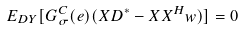<formula> <loc_0><loc_0><loc_500><loc_500>E _ { D Y } [ G ^ { C } _ { \sigma } ( e ) ( X D ^ { * } - X X ^ { H } w ) ] = 0</formula> 